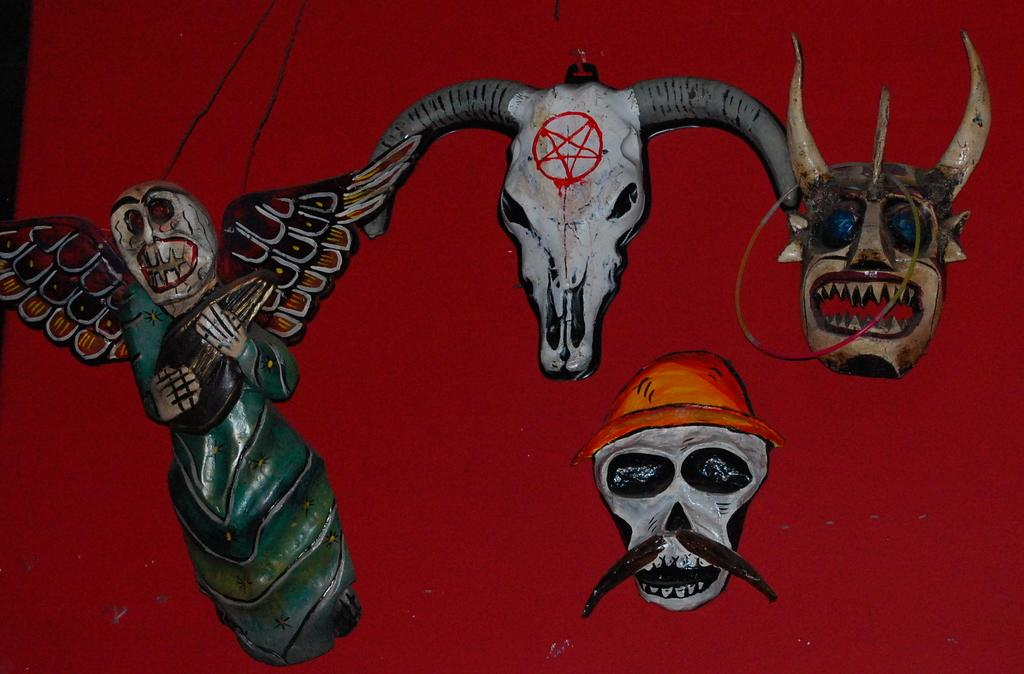What is the main subject of the image? There is a painting in the image. What is depicted in the painting? The painting depicts skulls. What color is the surface on which the painting is placed? The painting is on a red color surface. What type of advice can be seen written on the painting? There is no advice written on the painting; it depicts skulls on a red color surface. 